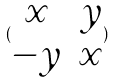<formula> <loc_0><loc_0><loc_500><loc_500>( \begin{matrix} x & y \\ - y & x \end{matrix} )</formula> 